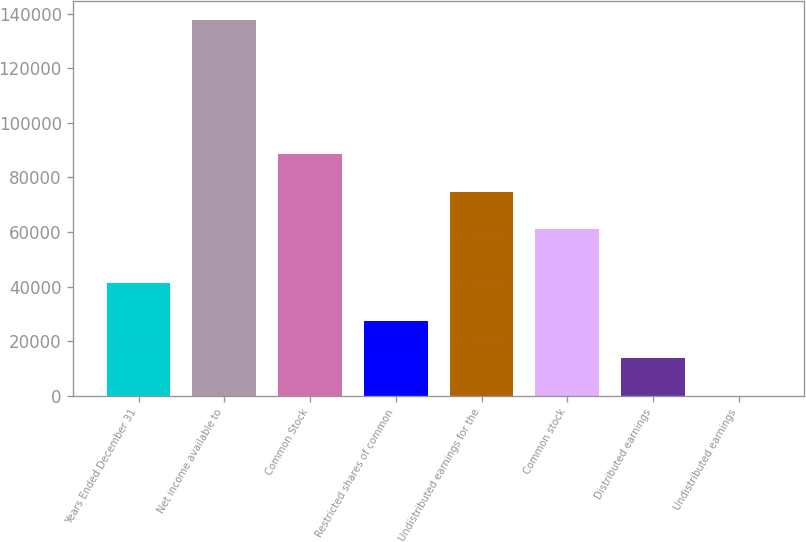<chart> <loc_0><loc_0><loc_500><loc_500><bar_chart><fcel>Years Ended December 31<fcel>Net income available to<fcel>Common Stock<fcel>Restricted shares of common<fcel>Undistributed earnings for the<fcel>Common stock<fcel>Distributed earnings<fcel>Undistributed earnings<nl><fcel>41299.5<fcel>137664<fcel>88533.7<fcel>27533.1<fcel>74767.4<fcel>61001<fcel>13766.8<fcel>0.42<nl></chart> 